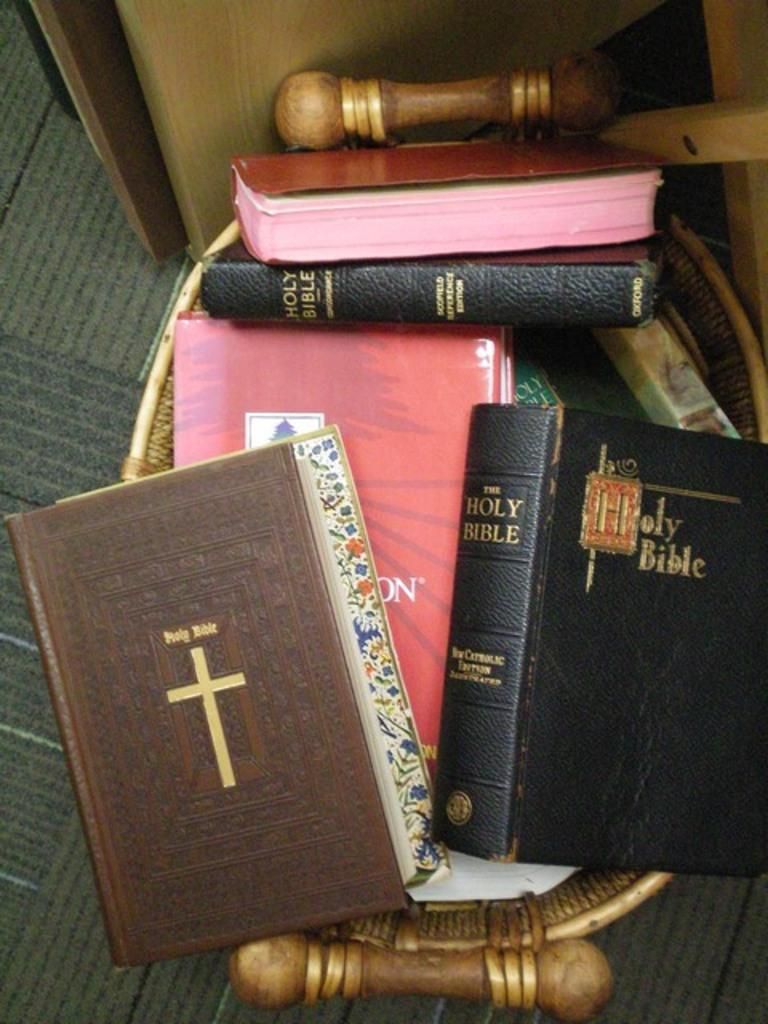<image>
Relay a brief, clear account of the picture shown. Multiple holy bible books stacked on top of each other 